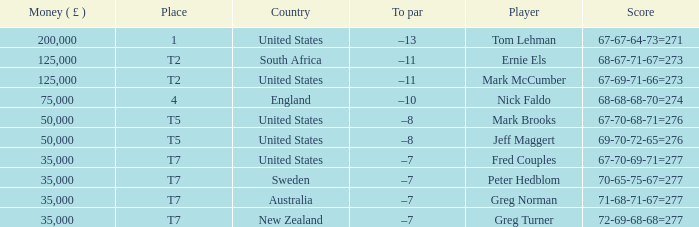What is the highest Money ( £ ), when Player is "Peter Hedblom"? 35000.0. 